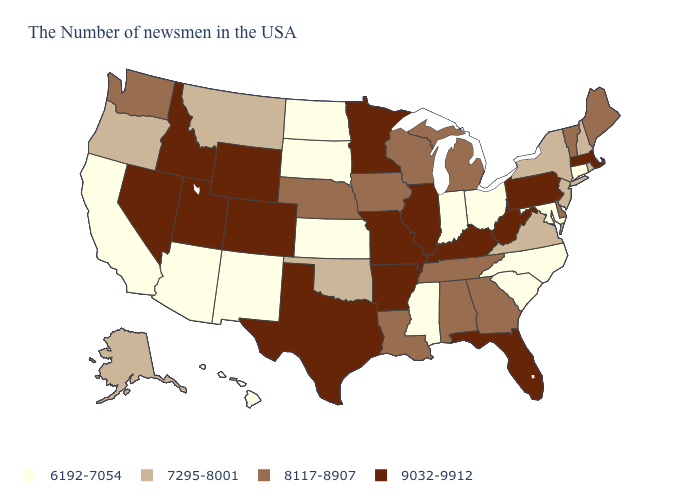Does Kentucky have the highest value in the USA?
Be succinct. Yes. Name the states that have a value in the range 6192-7054?
Short answer required. Connecticut, Maryland, North Carolina, South Carolina, Ohio, Indiana, Mississippi, Kansas, South Dakota, North Dakota, New Mexico, Arizona, California, Hawaii. Name the states that have a value in the range 6192-7054?
Short answer required. Connecticut, Maryland, North Carolina, South Carolina, Ohio, Indiana, Mississippi, Kansas, South Dakota, North Dakota, New Mexico, Arizona, California, Hawaii. Is the legend a continuous bar?
Give a very brief answer. No. Does the map have missing data?
Short answer required. No. What is the value of Montana?
Short answer required. 7295-8001. What is the value of Idaho?
Answer briefly. 9032-9912. What is the lowest value in states that border Wyoming?
Answer briefly. 6192-7054. Among the states that border Arizona , does California have the lowest value?
Short answer required. Yes. Among the states that border Arizona , which have the lowest value?
Answer briefly. New Mexico, California. What is the value of Pennsylvania?
Write a very short answer. 9032-9912. Name the states that have a value in the range 9032-9912?
Answer briefly. Massachusetts, Pennsylvania, West Virginia, Florida, Kentucky, Illinois, Missouri, Arkansas, Minnesota, Texas, Wyoming, Colorado, Utah, Idaho, Nevada. Name the states that have a value in the range 8117-8907?
Keep it brief. Maine, Vermont, Delaware, Georgia, Michigan, Alabama, Tennessee, Wisconsin, Louisiana, Iowa, Nebraska, Washington. Does the first symbol in the legend represent the smallest category?
Write a very short answer. Yes. What is the lowest value in the South?
Concise answer only. 6192-7054. 